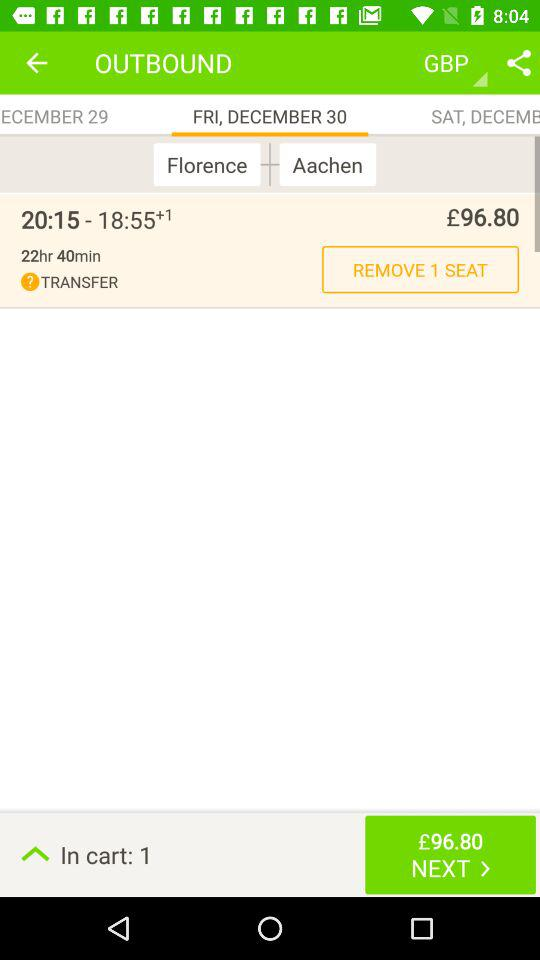What is the arrival time of the flight? The arrival time is 6:55 PM. 